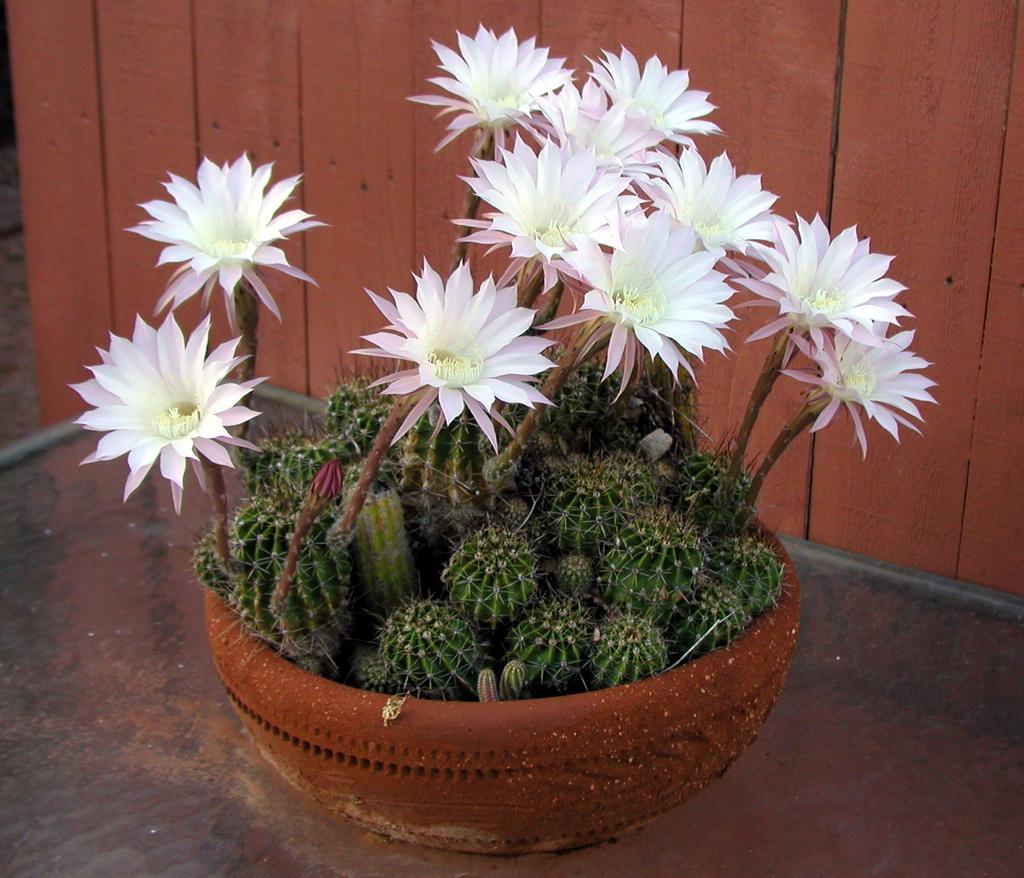Describe this image in one or two sentences. In this image we can see a potted plant with flowers. In the background, we can see a wall. 